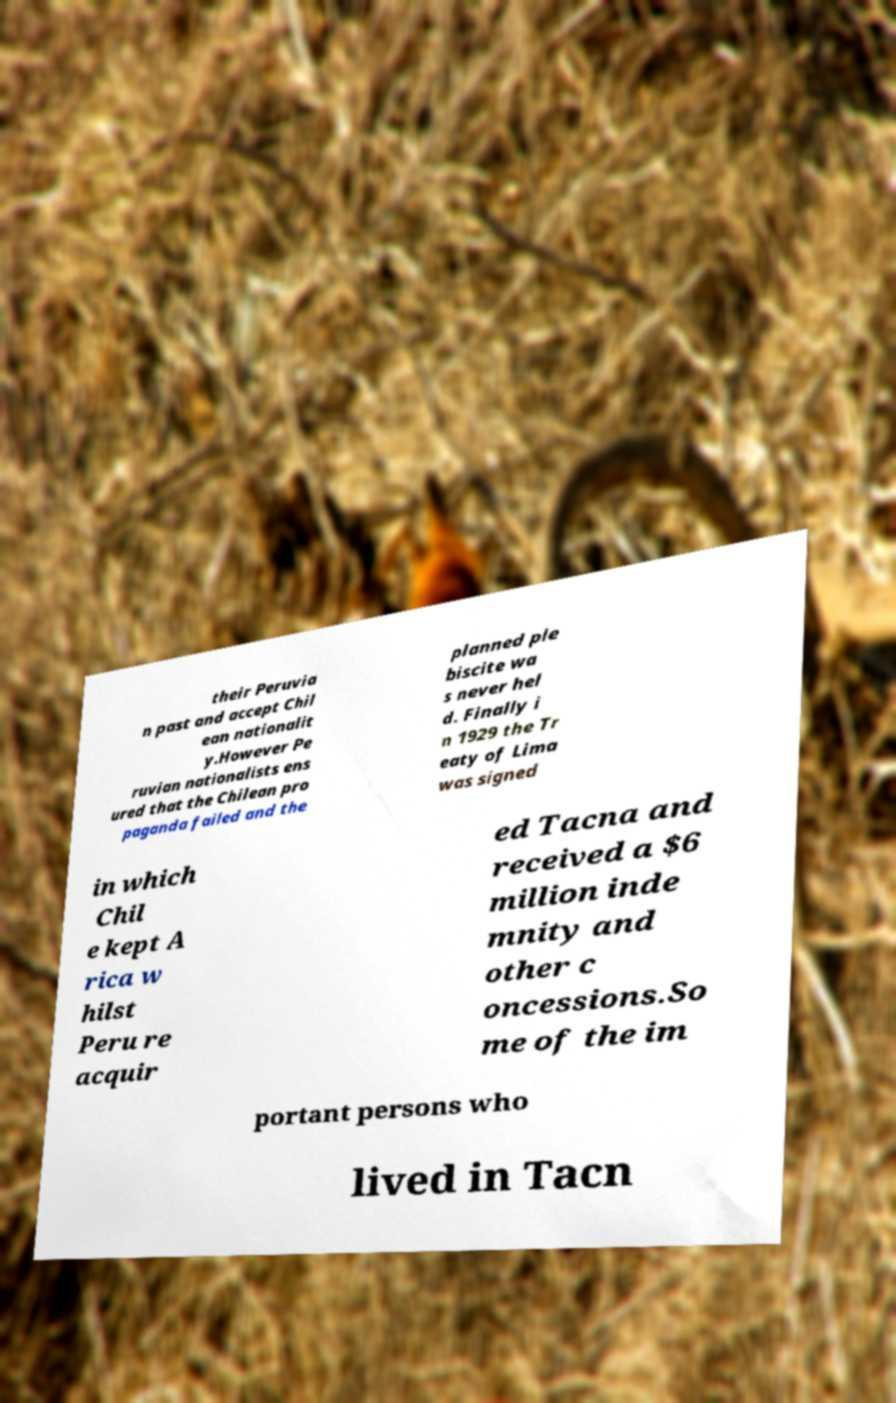There's text embedded in this image that I need extracted. Can you transcribe it verbatim? their Peruvia n past and accept Chil ean nationalit y.However Pe ruvian nationalists ens ured that the Chilean pro paganda failed and the planned ple biscite wa s never hel d. Finally i n 1929 the Tr eaty of Lima was signed in which Chil e kept A rica w hilst Peru re acquir ed Tacna and received a $6 million inde mnity and other c oncessions.So me of the im portant persons who lived in Tacn 